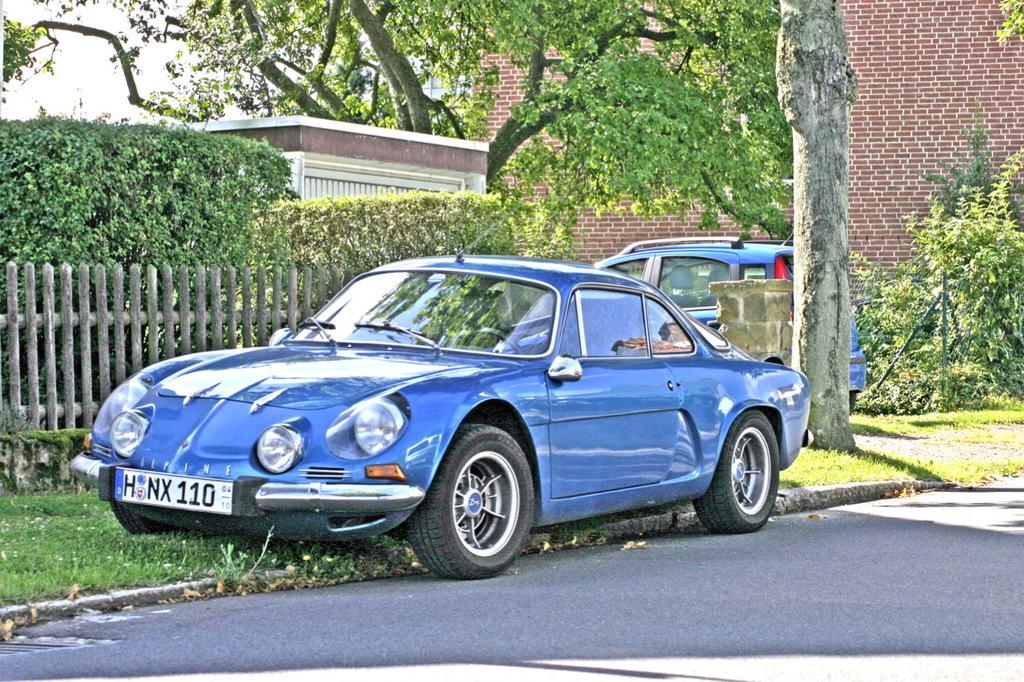What is the main feature in the center of the image? There is a sky in the center of the image. What type of natural elements can be seen in the image? There are trees, plants, and grass in the image. Can you describe any man-made structures in the image? There is one building, a brick wall, a pillar, a stand, a fence, and a road in the image. Are there any vehicles present in the image? Yes, there are vehicles in the image. What is the purpose of the stand in the image? The purpose of the stand cannot be determined from the image alone. What type of vase is placed on the stand in the image? There is no vase present on the stand in the image. What industry is depicted in the image? The image does not depict any specific industry. 